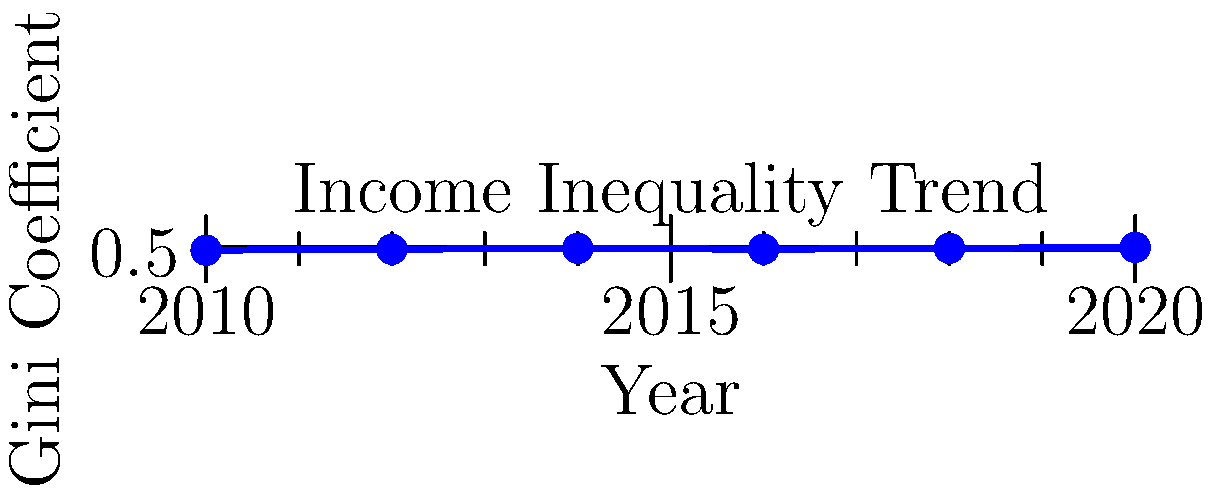The graph shows the trend of income inequality measured by the Gini coefficient in a country from 2010 to 2020. Based on this data and Christian teachings on wealth distribution, which of the following statements would be most consistent with a theological perspective on social justice?

A) The trend indicates God's favor on the wealthy.
B) The increasing inequality aligns with the concept of predestination.
C) The trend suggests a need for wealth redistribution to align with Christian principles of caring for the poor.
D) Income inequality is not relevant to Christian theology. To answer this question, we need to consider both the data presented in the graph and Christian teachings on wealth distribution:

1. Analyzing the graph:
   - The Gini coefficient ranges from 0 to 1, where 0 represents perfect equality and 1 represents perfect inequality.
   - The graph shows an overall increase in the Gini coefficient from 0.47 in 2010 to 0.50 in 2020.
   - This indicates a trend of increasing income inequality over the decade.

2. Christian teachings on wealth distribution:
   - The Bible emphasizes care for the poor and warns against the dangers of excessive wealth accumulation.
   - Jesus taught about the difficulty for the rich to enter the kingdom of God (Mark 10:25).
   - Early Christian communities practiced sharing of resources (Acts 4:32-35).
   - Many Christian theologians have interpreted these teachings as a call for social and economic justice.

3. Evaluating the options:
   A) This statement contradicts biblical teachings on wealth and poverty.
   B) Predestination is not directly related to economic inequality in Christian theology.
   C) This option aligns with Christian principles of social justice and care for the poor.
   D) This option ignores the significant emphasis on economic justice in Christian teachings.

4. Conclusion:
   Option C is most consistent with a Christian theological perspective on social justice, as it recognizes the need to address increasing inequality in light of biblical teachings on wealth distribution and care for the poor.
Answer: C 